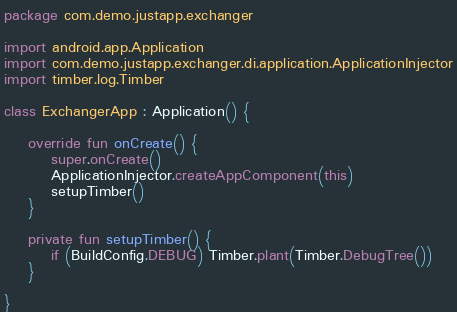Convert code to text. <code><loc_0><loc_0><loc_500><loc_500><_Kotlin_>package com.demo.justapp.exchanger

import android.app.Application
import com.demo.justapp.exchanger.di.application.ApplicationInjector
import timber.log.Timber

class ExchangerApp : Application() {

    override fun onCreate() {
        super.onCreate()
        ApplicationInjector.createAppComponent(this)
        setupTimber()
    }

    private fun setupTimber() {
        if (BuildConfig.DEBUG) Timber.plant(Timber.DebugTree())
    }

}</code> 